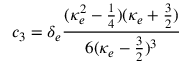<formula> <loc_0><loc_0><loc_500><loc_500>c _ { 3 } = \delta _ { e } \frac { ( \kappa _ { e } ^ { 2 } - \frac { 1 } { 4 } ) ( \kappa _ { e } + \frac { 3 } { 2 } ) } { 6 ( \kappa _ { e } - \frac { 3 } { 2 } ) ^ { 3 } }</formula> 